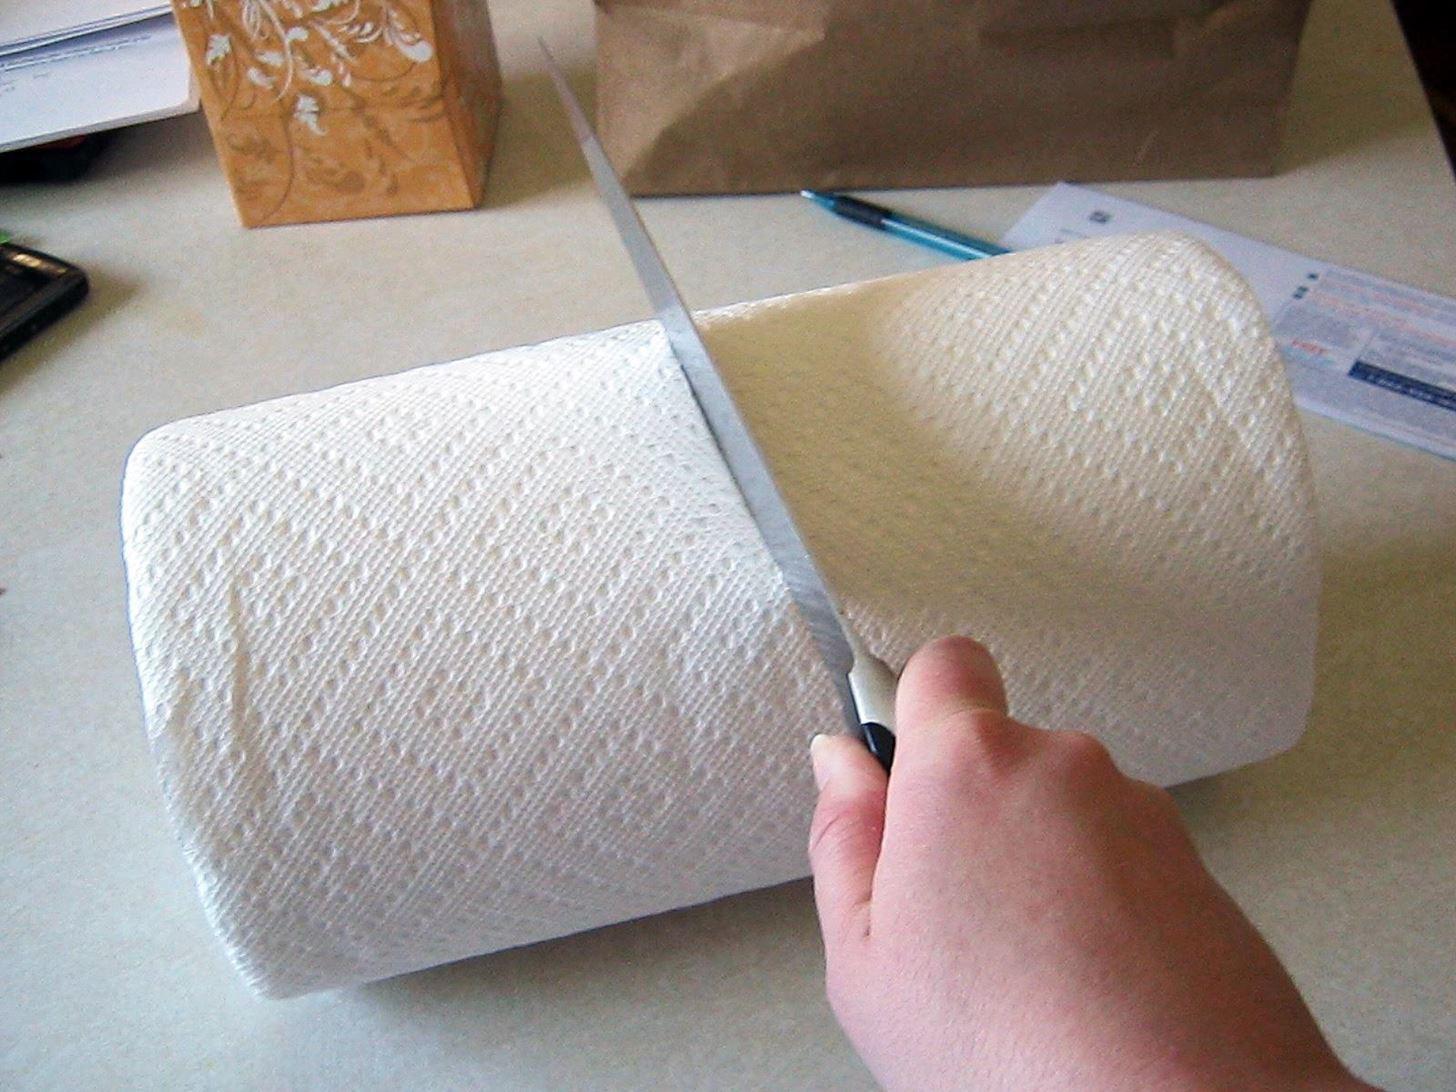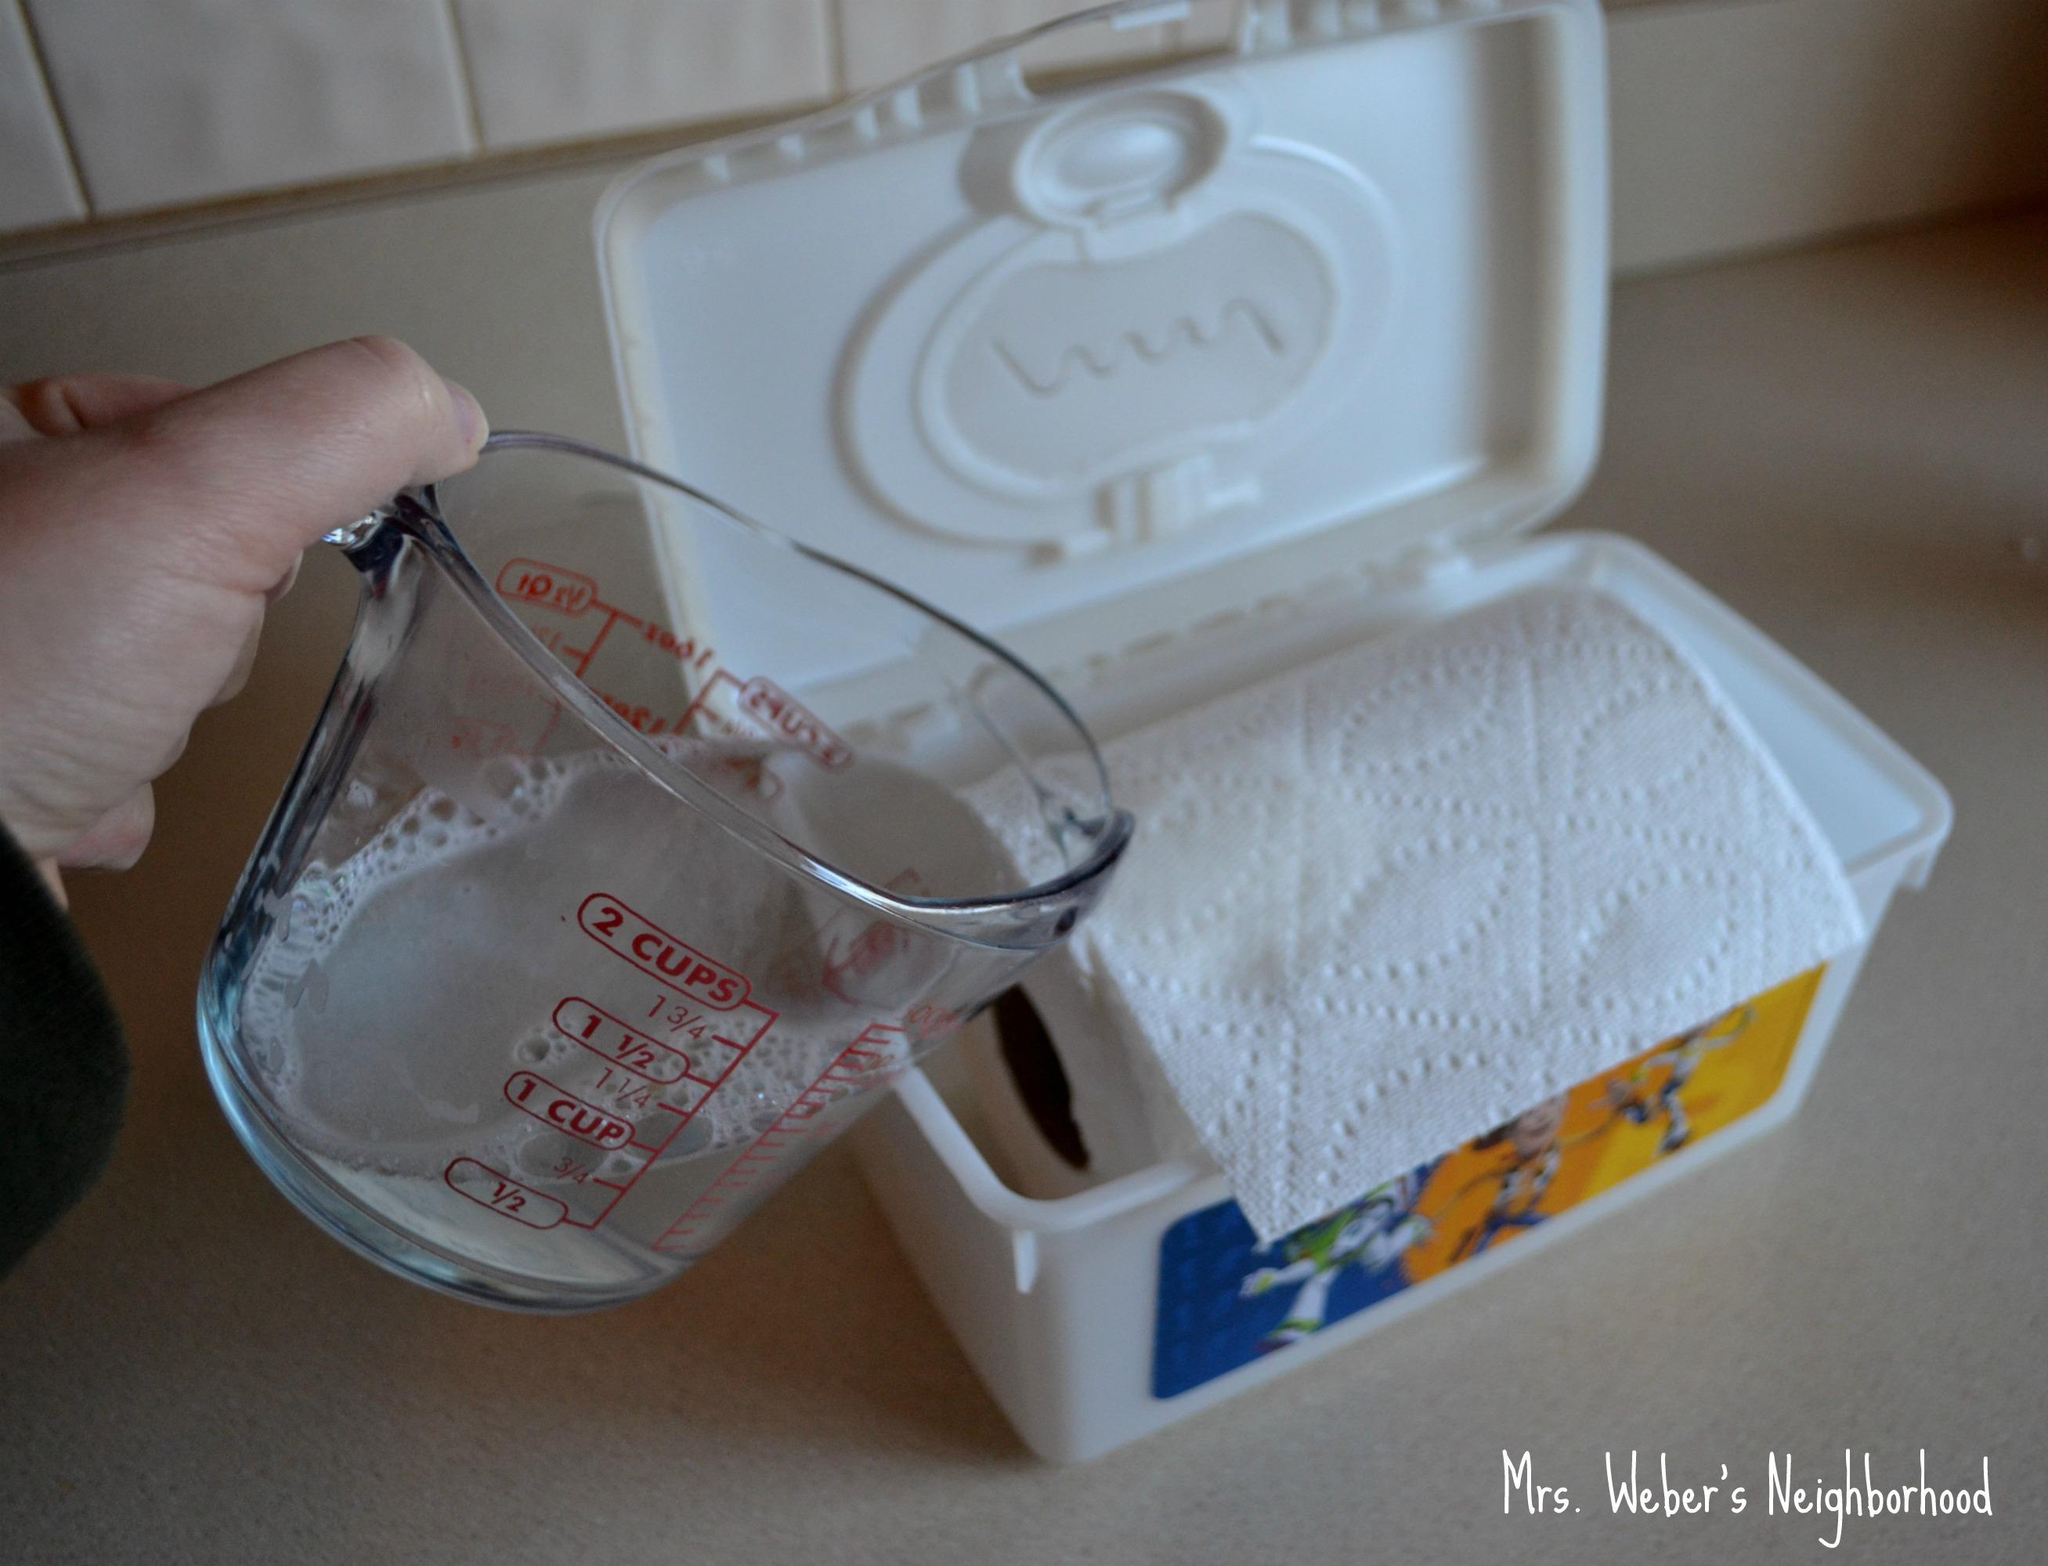The first image is the image on the left, the second image is the image on the right. Examine the images to the left and right. Is the description "The container in the image on the right is round." accurate? Answer yes or no. No. 